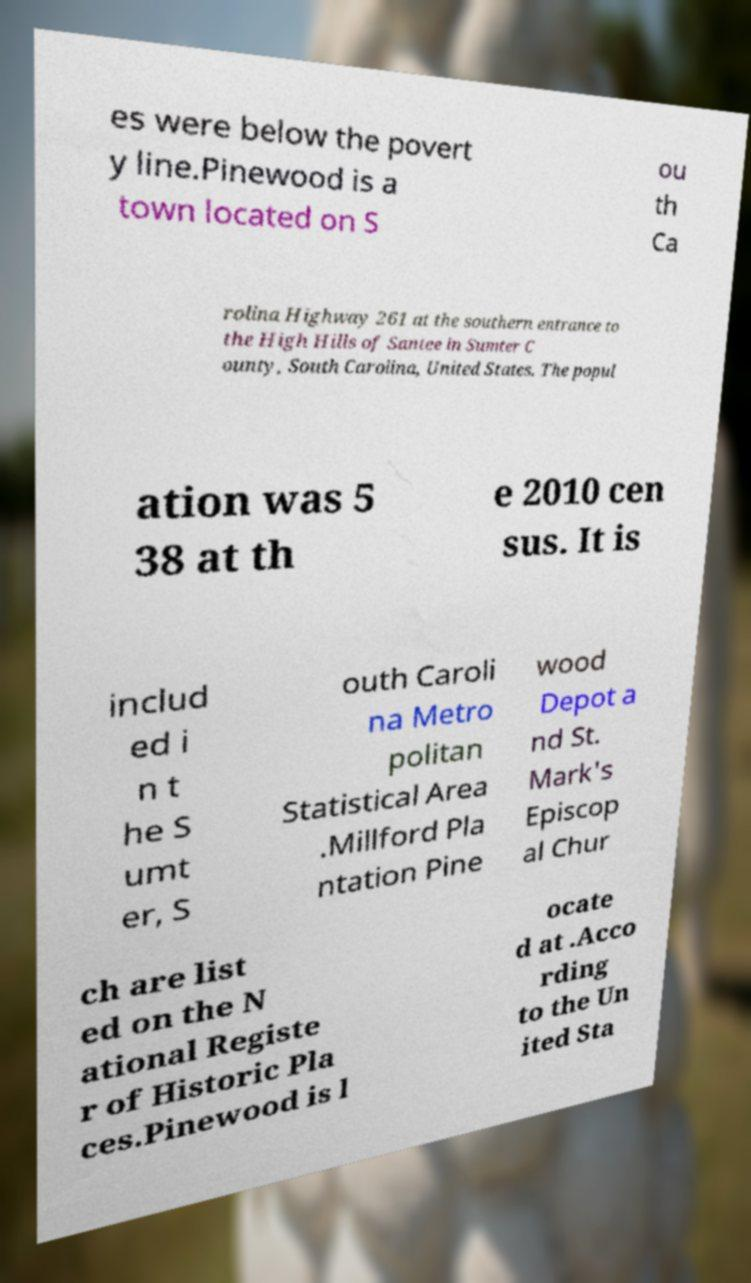What messages or text are displayed in this image? I need them in a readable, typed format. es were below the povert y line.Pinewood is a town located on S ou th Ca rolina Highway 261 at the southern entrance to the High Hills of Santee in Sumter C ounty, South Carolina, United States. The popul ation was 5 38 at th e 2010 cen sus. It is includ ed i n t he S umt er, S outh Caroli na Metro politan Statistical Area .Millford Pla ntation Pine wood Depot a nd St. Mark's Episcop al Chur ch are list ed on the N ational Registe r of Historic Pla ces.Pinewood is l ocate d at .Acco rding to the Un ited Sta 